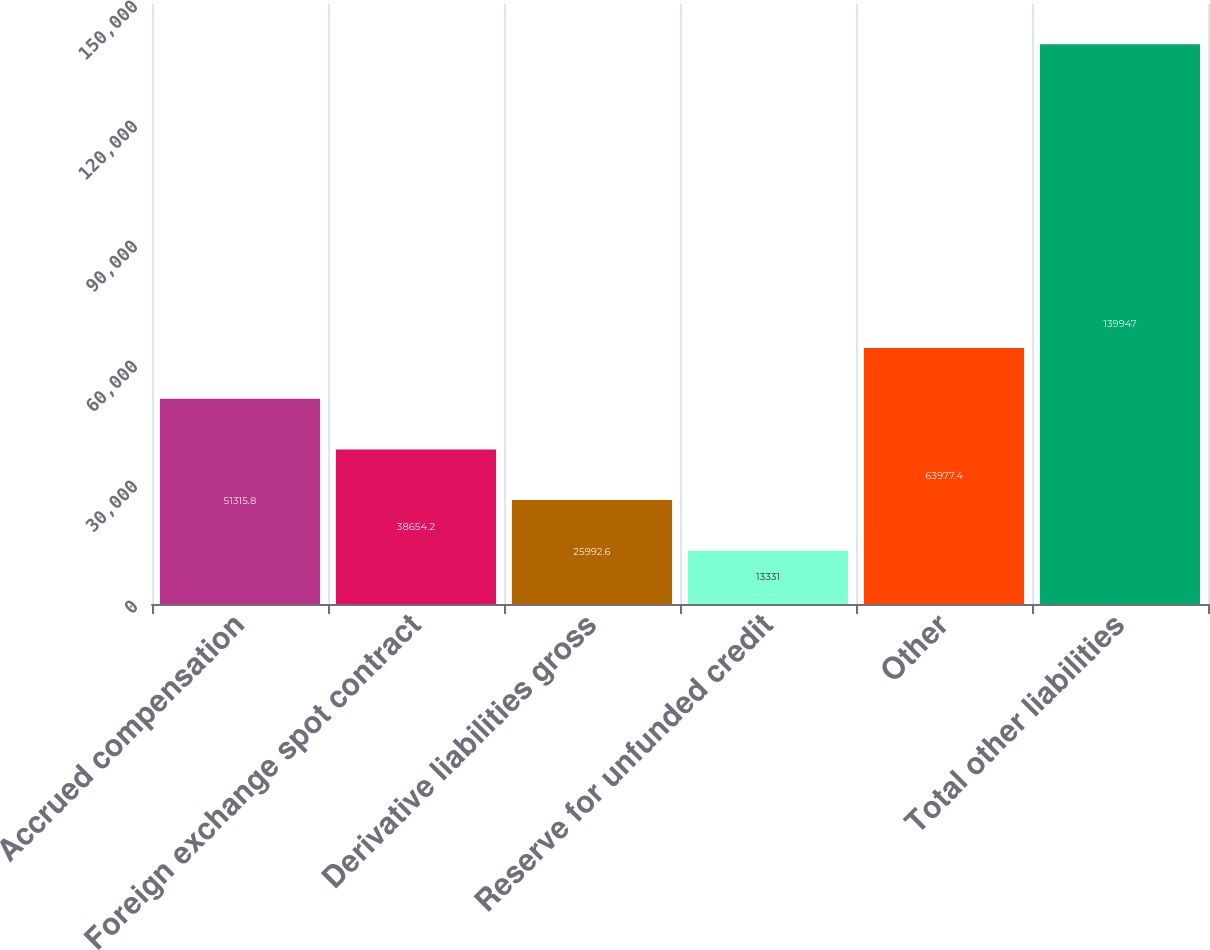Convert chart. <chart><loc_0><loc_0><loc_500><loc_500><bar_chart><fcel>Accrued compensation<fcel>Foreign exchange spot contract<fcel>Derivative liabilities gross<fcel>Reserve for unfunded credit<fcel>Other<fcel>Total other liabilities<nl><fcel>51315.8<fcel>38654.2<fcel>25992.6<fcel>13331<fcel>63977.4<fcel>139947<nl></chart> 